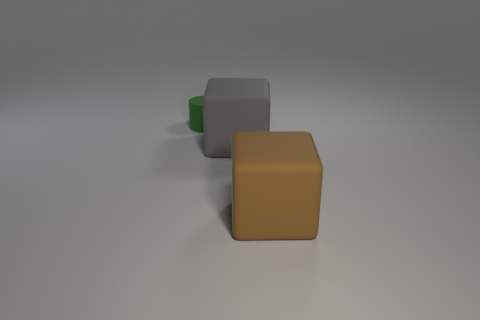Add 2 tiny blue rubber blocks. How many objects exist? 5 Subtract all cylinders. How many objects are left? 2 Subtract 0 blue blocks. How many objects are left? 3 Subtract all small matte objects. Subtract all large gray rubber objects. How many objects are left? 1 Add 1 gray things. How many gray things are left? 2 Add 2 small gray metal things. How many small gray metal things exist? 2 